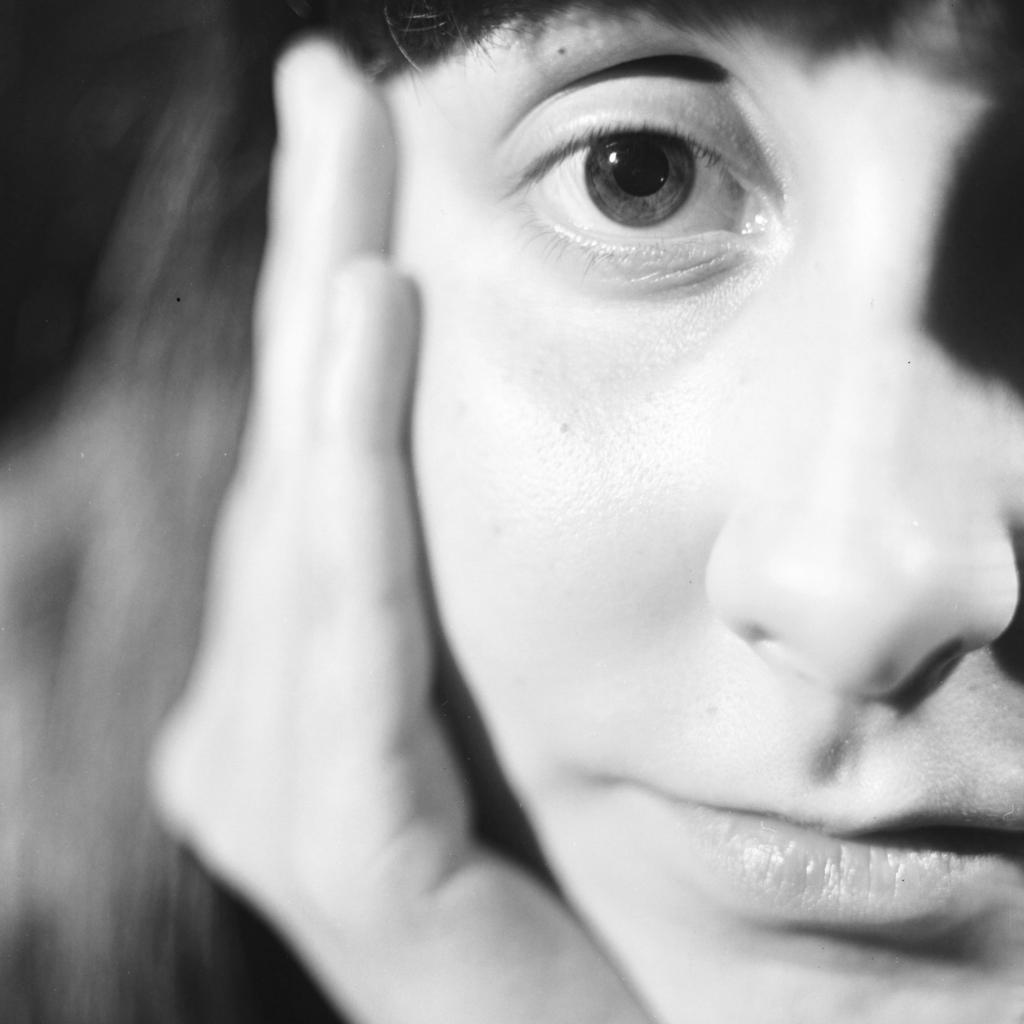What is the color scheme of the image? The image is black and white. What is the main subject of the image? There is a woman in the image. What is the woman doing in the image? The woman is placing her head on her hand. Is the woman in the image giving driving advice to someone? There is no indication in the image that the woman is giving driving advice to someone. Is there a camera visible in the image? There is no camera visible in the image. 